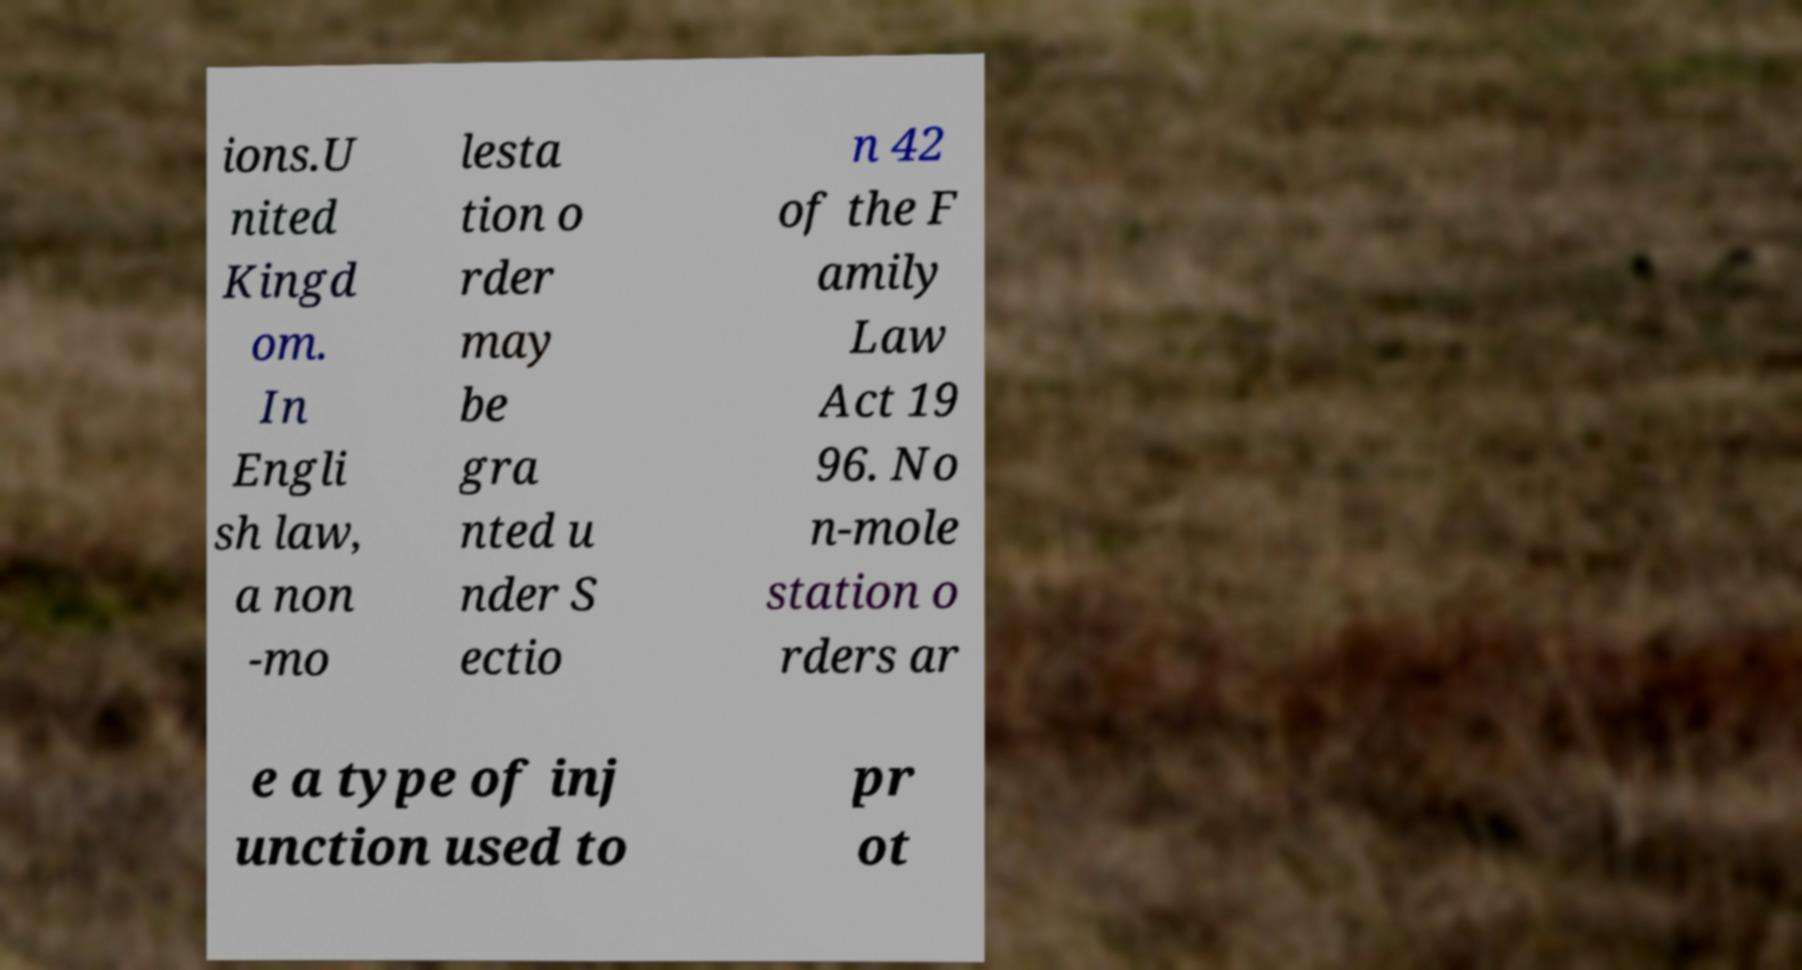For documentation purposes, I need the text within this image transcribed. Could you provide that? ions.U nited Kingd om. In Engli sh law, a non -mo lesta tion o rder may be gra nted u nder S ectio n 42 of the F amily Law Act 19 96. No n-mole station o rders ar e a type of inj unction used to pr ot 